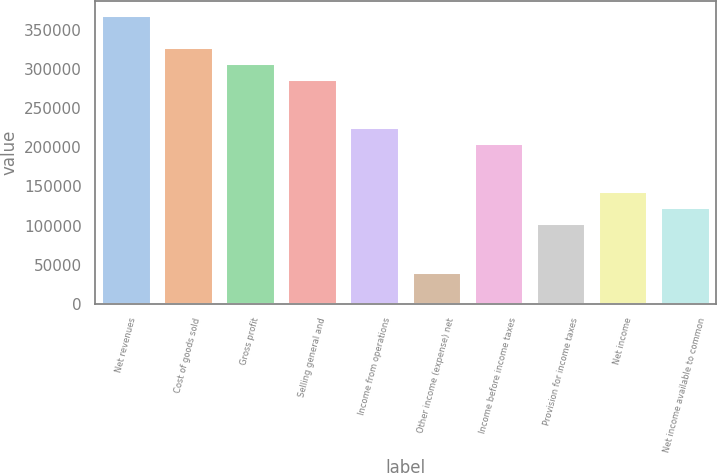Convert chart. <chart><loc_0><loc_0><loc_500><loc_500><bar_chart><fcel>Net revenues<fcel>Cost of goods sold<fcel>Gross profit<fcel>Selling general and<fcel>Income from operations<fcel>Other income (expense) net<fcel>Income before income taxes<fcel>Provision for income taxes<fcel>Net income<fcel>Net income available to common<nl><fcel>369325<fcel>328289<fcel>307771<fcel>287253<fcel>225699<fcel>41036.5<fcel>205181<fcel>102591<fcel>143627<fcel>123109<nl></chart> 